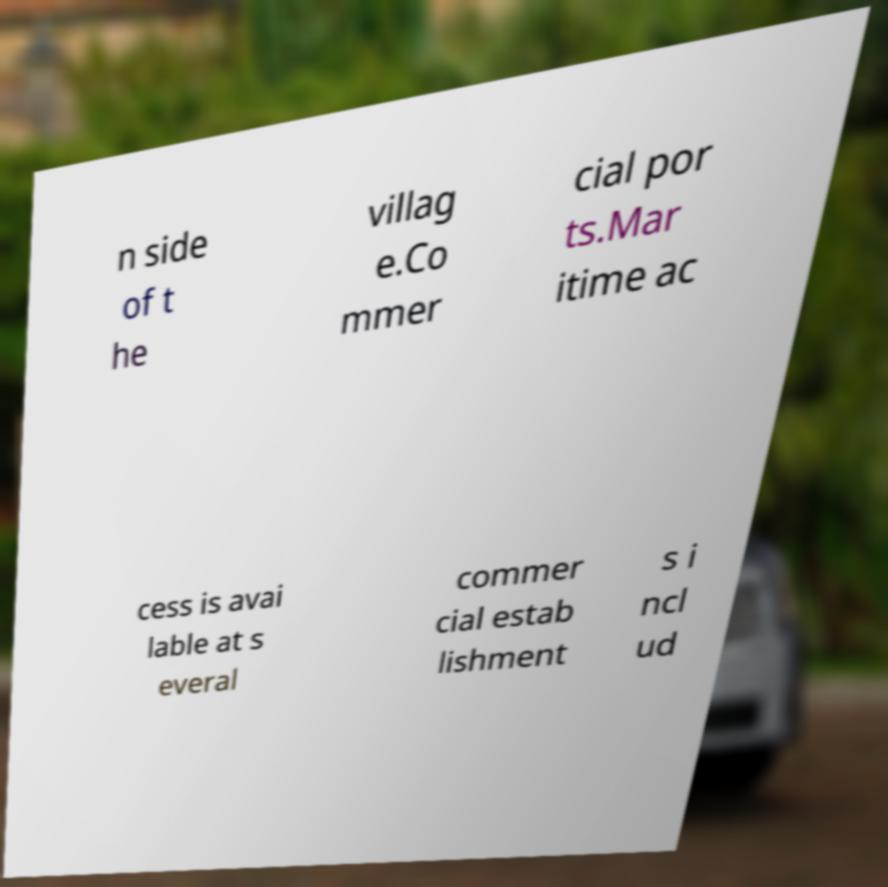Could you extract and type out the text from this image? n side of t he villag e.Co mmer cial por ts.Mar itime ac cess is avai lable at s everal commer cial estab lishment s i ncl ud 